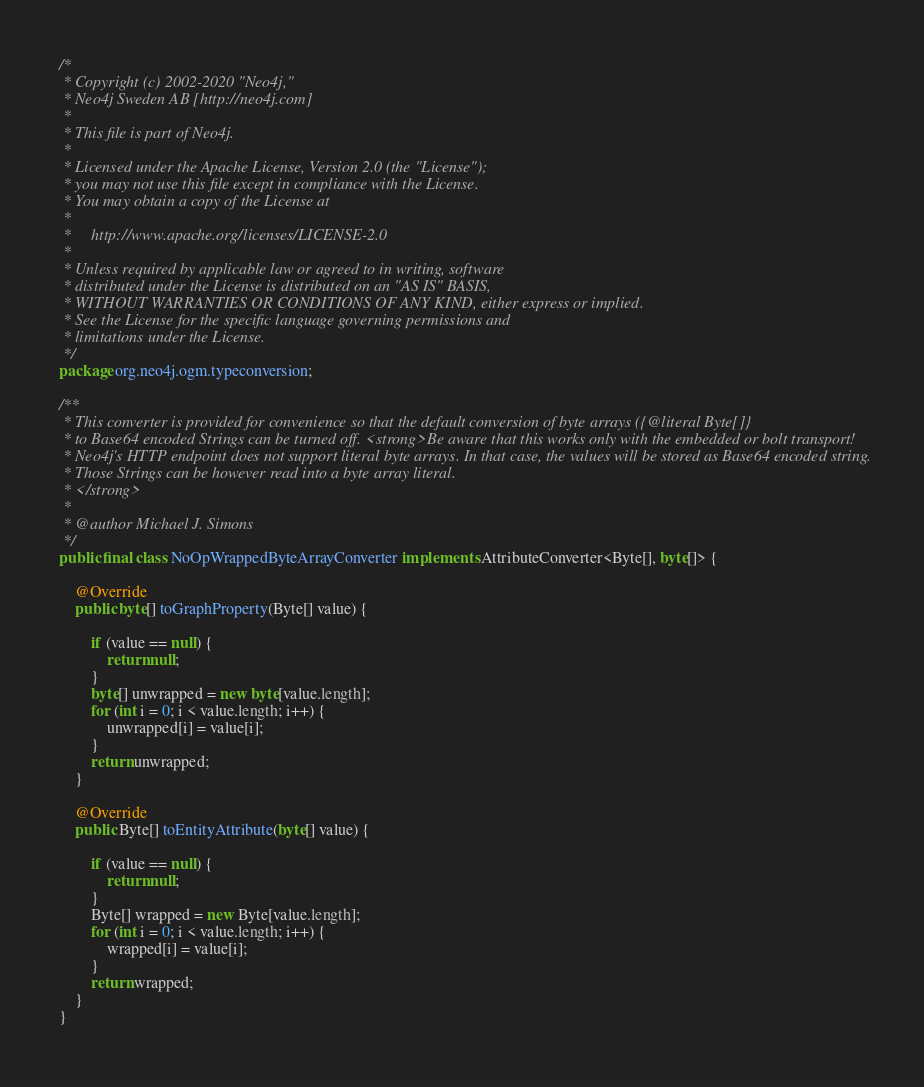Convert code to text. <code><loc_0><loc_0><loc_500><loc_500><_Java_>/*
 * Copyright (c) 2002-2020 "Neo4j,"
 * Neo4j Sweden AB [http://neo4j.com]
 *
 * This file is part of Neo4j.
 *
 * Licensed under the Apache License, Version 2.0 (the "License");
 * you may not use this file except in compliance with the License.
 * You may obtain a copy of the License at
 *
 *     http://www.apache.org/licenses/LICENSE-2.0
 *
 * Unless required by applicable law or agreed to in writing, software
 * distributed under the License is distributed on an "AS IS" BASIS,
 * WITHOUT WARRANTIES OR CONDITIONS OF ANY KIND, either express or implied.
 * See the License for the specific language governing permissions and
 * limitations under the License.
 */
package org.neo4j.ogm.typeconversion;

/**
 * This converter is provided for convenience so that the default conversion of byte arrays ({@literal Byte[]}
 * to Base64 encoded Strings can be turned off. <strong>Be aware that this works only with the embedded or bolt transport!
 * Neo4j's HTTP endpoint does not support literal byte arrays. In that case, the values will be stored as Base64 encoded string.
 * Those Strings can be however read into a byte array literal.
 * </strong>
 *
 * @author Michael J. Simons
 */
public final class NoOpWrappedByteArrayConverter implements AttributeConverter<Byte[], byte[]> {

    @Override
    public byte[] toGraphProperty(Byte[] value) {

        if (value == null) {
            return null;
        }
        byte[] unwrapped = new byte[value.length];
        for (int i = 0; i < value.length; i++) {
            unwrapped[i] = value[i];
        }
        return unwrapped;
    }

    @Override
    public Byte[] toEntityAttribute(byte[] value) {

        if (value == null) {
            return null;
        }
        Byte[] wrapped = new Byte[value.length];
        for (int i = 0; i < value.length; i++) {
            wrapped[i] = value[i];
        }
        return wrapped;
    }
}
</code> 